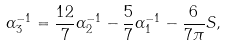<formula> <loc_0><loc_0><loc_500><loc_500>\alpha _ { 3 } ^ { - 1 } = \frac { 1 2 } { 7 } \alpha _ { 2 } ^ { - 1 } - \frac { 5 } { 7 } \alpha _ { 1 } ^ { - 1 } - \frac { 6 } { 7 \pi } S ,</formula> 